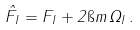Convert formula to latex. <formula><loc_0><loc_0><loc_500><loc_500>\hat { F } _ { I } = F _ { I } + 2 \i m \, \Omega _ { I } \, .</formula> 